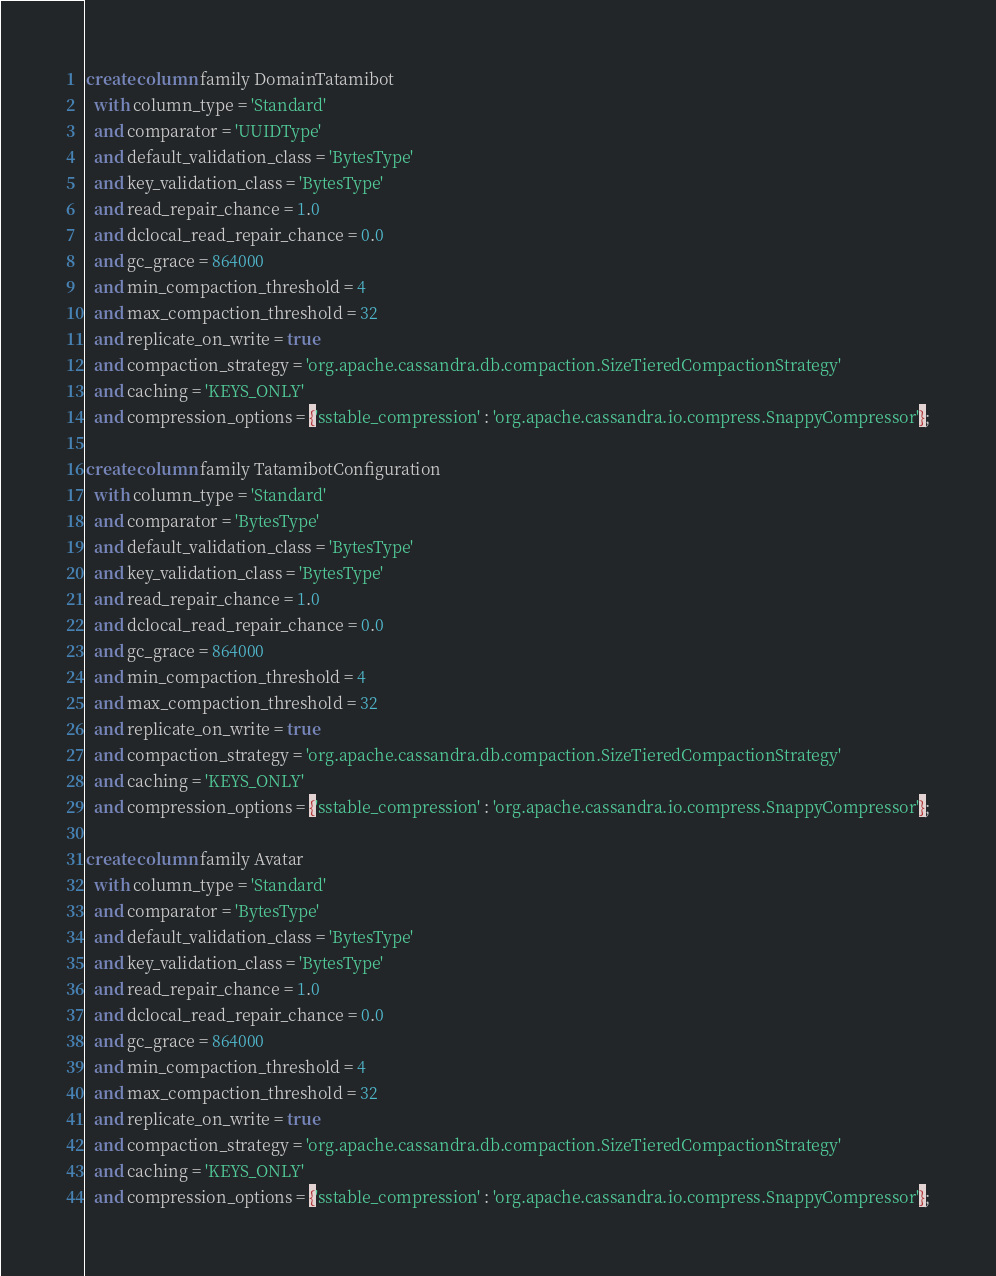Convert code to text. <code><loc_0><loc_0><loc_500><loc_500><_SQL_>create column family DomainTatamibot
  with column_type = 'Standard'
  and comparator = 'UUIDType'
  and default_validation_class = 'BytesType'
  and key_validation_class = 'BytesType'
  and read_repair_chance = 1.0
  and dclocal_read_repair_chance = 0.0
  and gc_grace = 864000
  and min_compaction_threshold = 4
  and max_compaction_threshold = 32
  and replicate_on_write = true
  and compaction_strategy = 'org.apache.cassandra.db.compaction.SizeTieredCompactionStrategy'
  and caching = 'KEYS_ONLY'
  and compression_options = {'sstable_compression' : 'org.apache.cassandra.io.compress.SnappyCompressor'};

create column family TatamibotConfiguration
  with column_type = 'Standard'
  and comparator = 'BytesType'
  and default_validation_class = 'BytesType'
  and key_validation_class = 'BytesType'
  and read_repair_chance = 1.0
  and dclocal_read_repair_chance = 0.0
  and gc_grace = 864000
  and min_compaction_threshold = 4
  and max_compaction_threshold = 32
  and replicate_on_write = true
  and compaction_strategy = 'org.apache.cassandra.db.compaction.SizeTieredCompactionStrategy'
  and caching = 'KEYS_ONLY'
  and compression_options = {'sstable_compression' : 'org.apache.cassandra.io.compress.SnappyCompressor'};

create column family Avatar
  with column_type = 'Standard'
  and comparator = 'BytesType'
  and default_validation_class = 'BytesType'
  and key_validation_class = 'BytesType'
  and read_repair_chance = 1.0
  and dclocal_read_repair_chance = 0.0
  and gc_grace = 864000
  and min_compaction_threshold = 4
  and max_compaction_threshold = 32
  and replicate_on_write = true
  and compaction_strategy = 'org.apache.cassandra.db.compaction.SizeTieredCompactionStrategy'
  and caching = 'KEYS_ONLY'
  and compression_options = {'sstable_compression' : 'org.apache.cassandra.io.compress.SnappyCompressor'};

</code> 